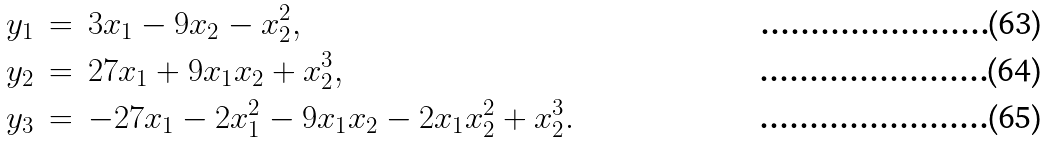<formula> <loc_0><loc_0><loc_500><loc_500>y _ { 1 } \, & = \, 3 x _ { 1 } - 9 x _ { 2 } - x _ { 2 } ^ { 2 } , \\ y _ { 2 } \, & = \, 2 7 x _ { 1 } + 9 x _ { 1 } x _ { 2 } + x _ { 2 } ^ { 3 } , \\ y _ { 3 } \, & = \, - 2 7 x _ { 1 } - 2 x _ { 1 } ^ { 2 } - 9 x _ { 1 } x _ { 2 } - 2 x _ { 1 } x _ { 2 } ^ { 2 } + x _ { 2 } ^ { 3 } .</formula> 